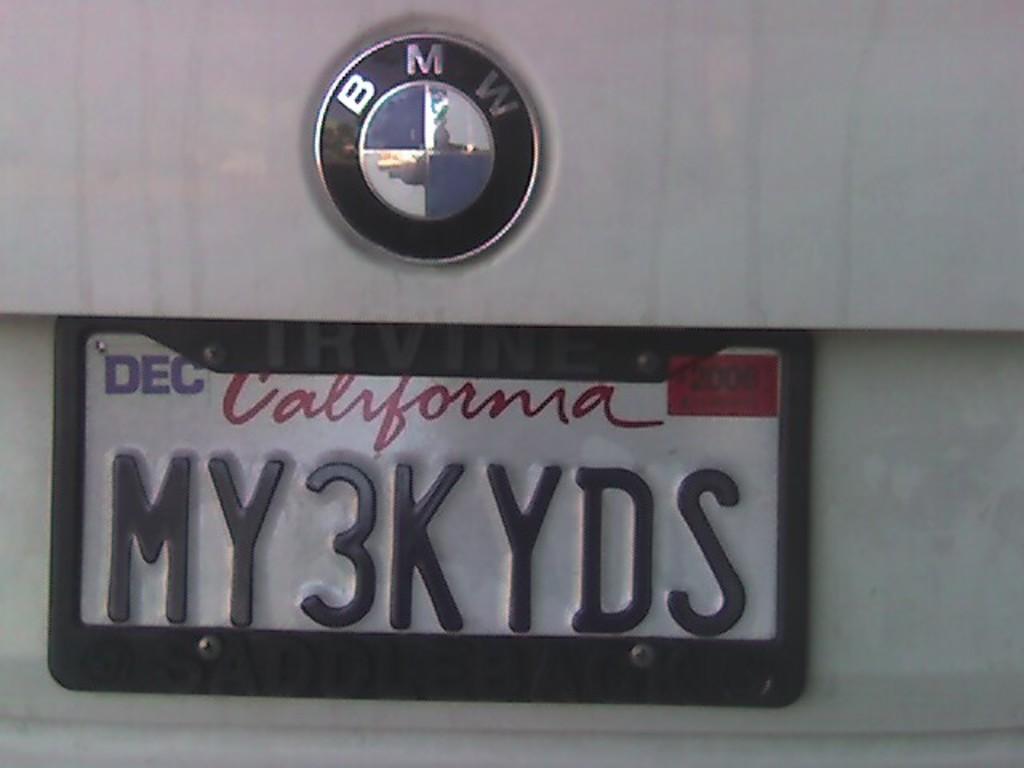Describe this image in one or two sentences. In this picture I can see a BMW logo and a number plate on the vehicle. 